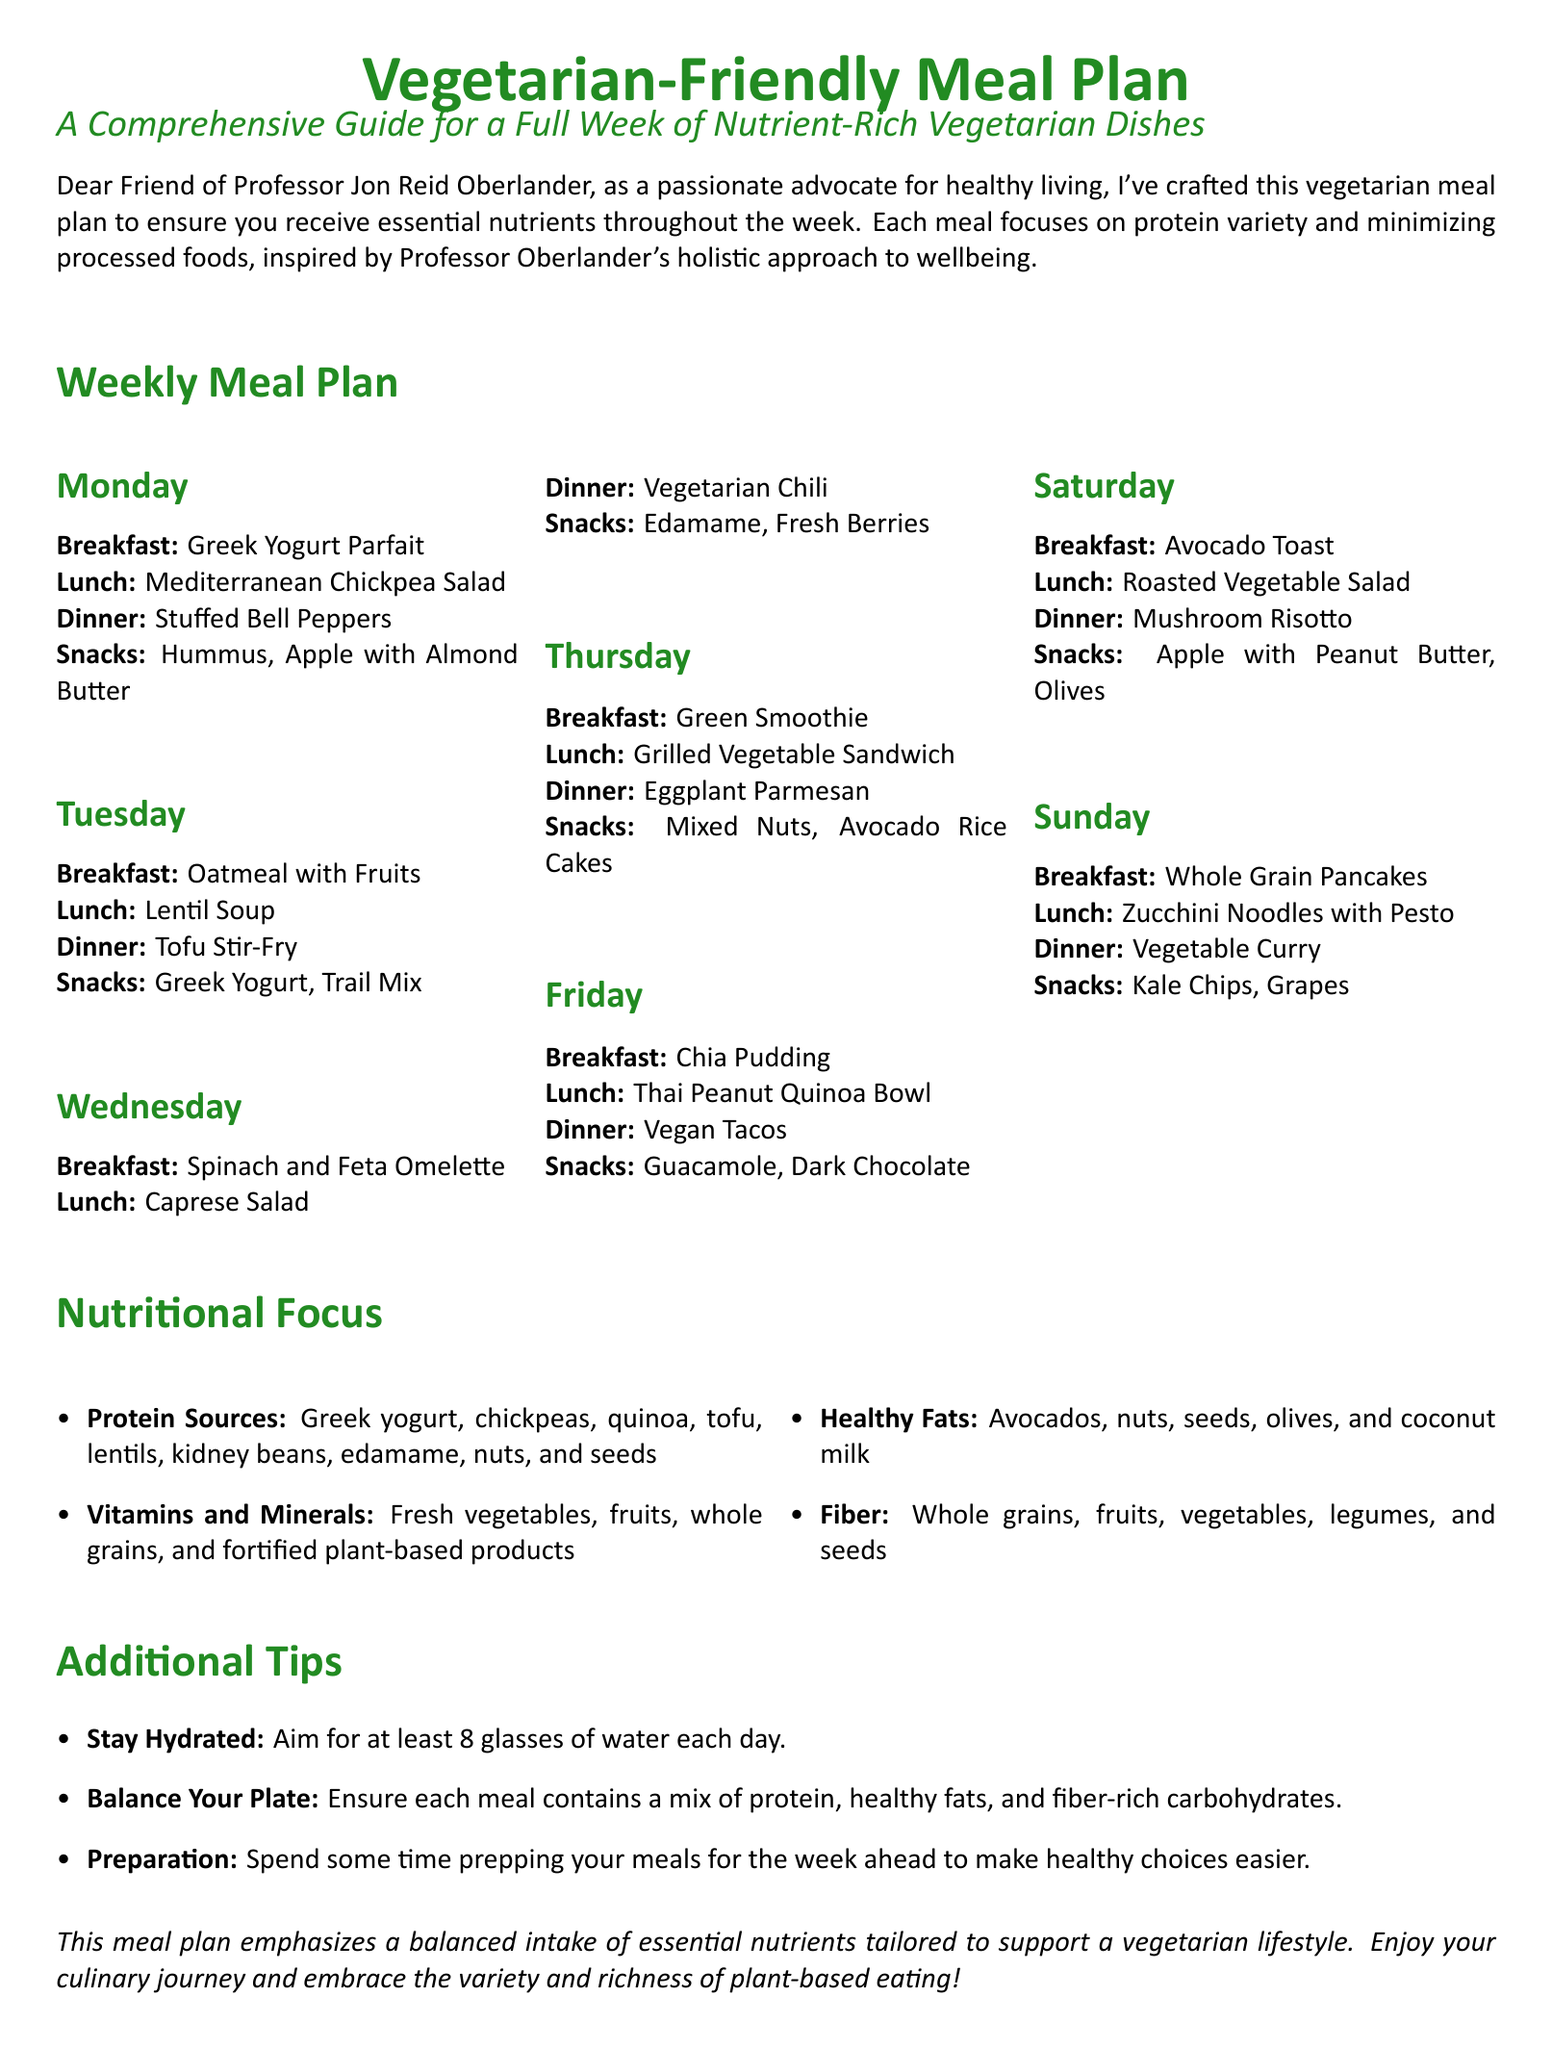What is the title of the meal plan? The title of the meal plan is clearly stated at the top of the document.
Answer: Vegetarian-Friendly Meal Plan How many meals are listed for each day? The meal plan provides a specific count of meals for each day, which includes breakfast, lunch, dinner, and snacks.
Answer: Four What ingredient is used for Monday's lunch? The meal plan lists specific meals for each lunch throughout the week.
Answer: Mediterranean Chickpea Salad Which day features Avocado Toast for breakfast? The meal plan specifies breakfast meals for each day.
Answer: Saturday What is one source of healthy fats mentioned in the nutritional focus section? The nutritional focus section lists sources of healthy fats in the vegetarian diet.
Answer: Avocados How many types of protein sources are listed in the nutritional focus? The document outlines various protein sources that are essential for the meal plan.
Answer: Nine What type of soup is included in Tuesday's lunch? The meal plan describes specific meals provided for lunch each day.
Answer: Lentil Soup What should you aim for in terms of water intake according to the additional tips? The additional tips section provides guidance on hydration for individuals following the meal plan.
Answer: At least 8 glasses What is the dinner meal suggested for Friday? The document lists different meals for each day of the week, including dinner options.
Answer: Vegan Tacos 